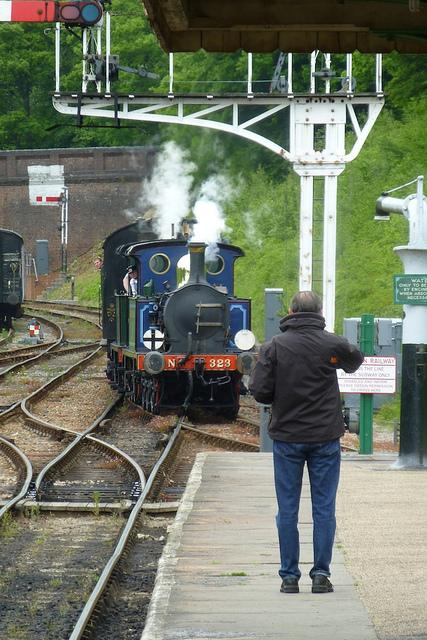Why are the people travelling on the train?

Choices:
A) eating food
B) learning driving
C) commuting
D) touring touring 